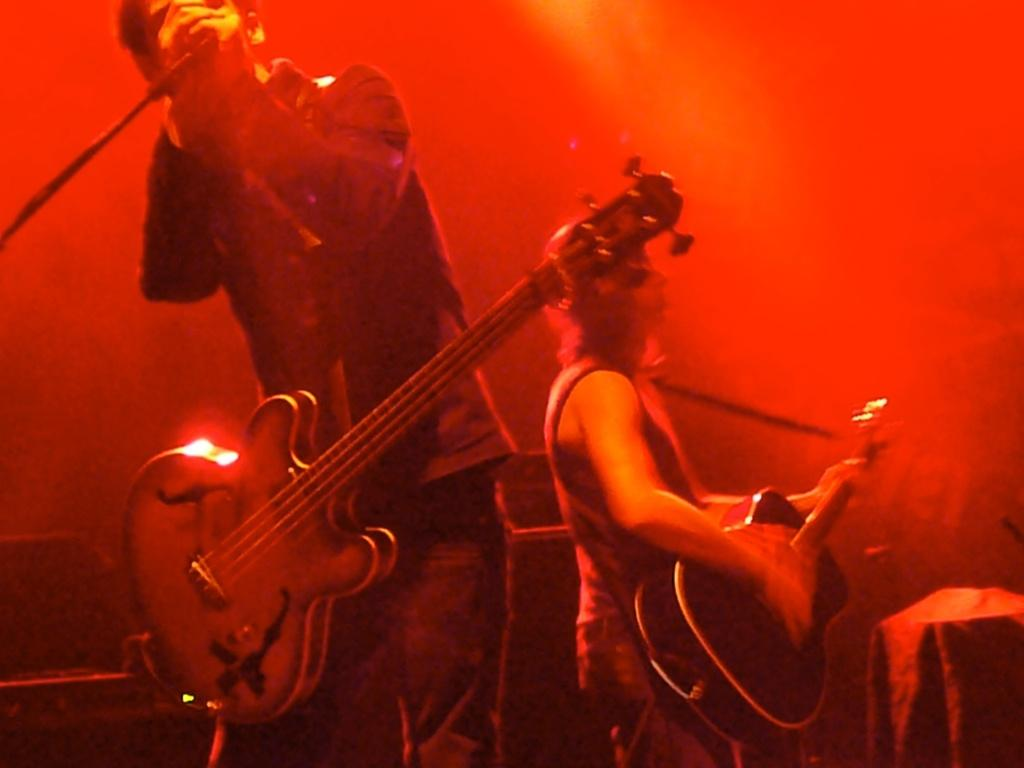Who is the main subject in the image? There is a man in the image. Where is the man positioned in the image? The man is standing on the left side. What is the man doing in the image? The man is singing into a microphone. What is the man wearing in the image? The man is wearing a guitar. What type of crime is being committed by the beetle in the image? There is no beetle present in the image, and therefore no crime can be committed by a beetle. 